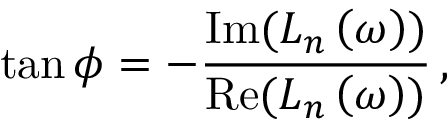<formula> <loc_0><loc_0><loc_500><loc_500>\tan \phi = - \frac { I m ( L _ { n } \left ( \omega \right ) ) } { R e ( L _ { n } \left ( \omega \right ) ) } \, ,</formula> 